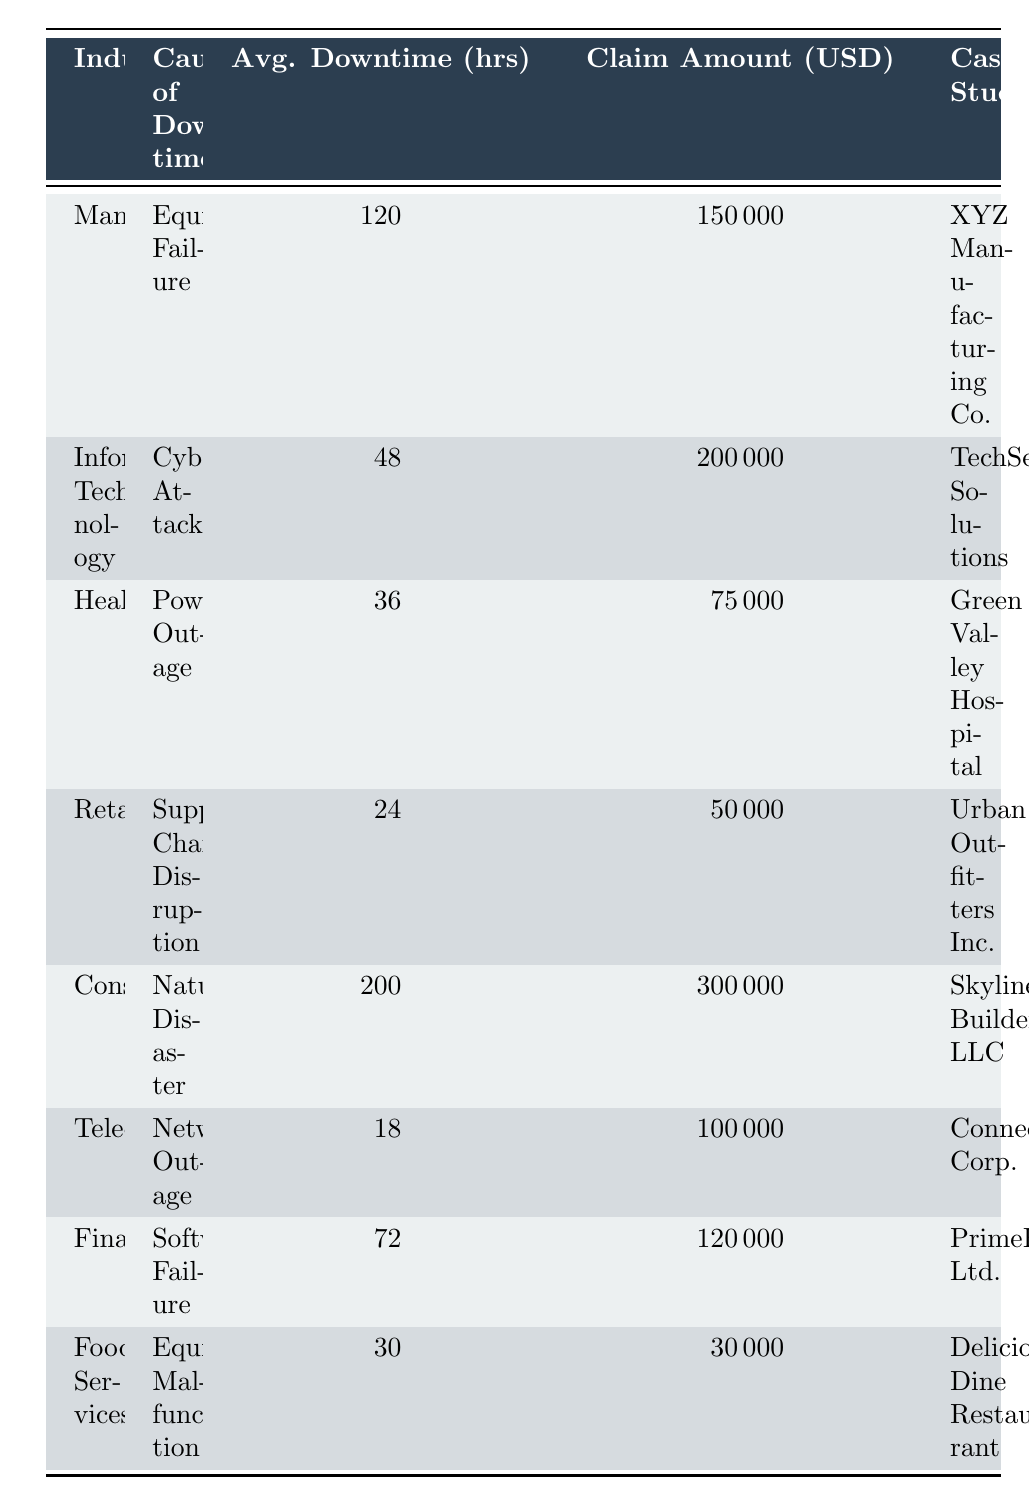What is the cause of downtime for Urban Outfitters Inc.? From the table, we can find the case study listed under the Retail industry, which states that the cause of downtime is Supply Chain Disruption.
Answer: Supply Chain Disruption Which industry has the highest average downtime hours? By looking at the "Avg. Downtime (hrs)" column, we see that Construction has the highest value at 200 hours, compared to other industries listed.
Answer: Construction What is the total claim amount for all the industries? We need to sum the claim amounts: 150000 + 200000 + 75000 + 50000 + 300000 + 100000 + 120000 + 30000 = 1050000.
Answer: 1050000 Is the average downtime for the Healthcare industry greater than 40 hours? Looking at the table, the average downtime for Healthcare is 36 hours, which is less than 40 hours. Therefore, the answer is no.
Answer: No Which cause of downtime leads to the highest claim amount and what is that amount? Reviewing the "Claim Amount (USD)" column, we see that Natural Disaster in the Construction industry leads to the highest claim amount of 300000 USD.
Answer: 300000 